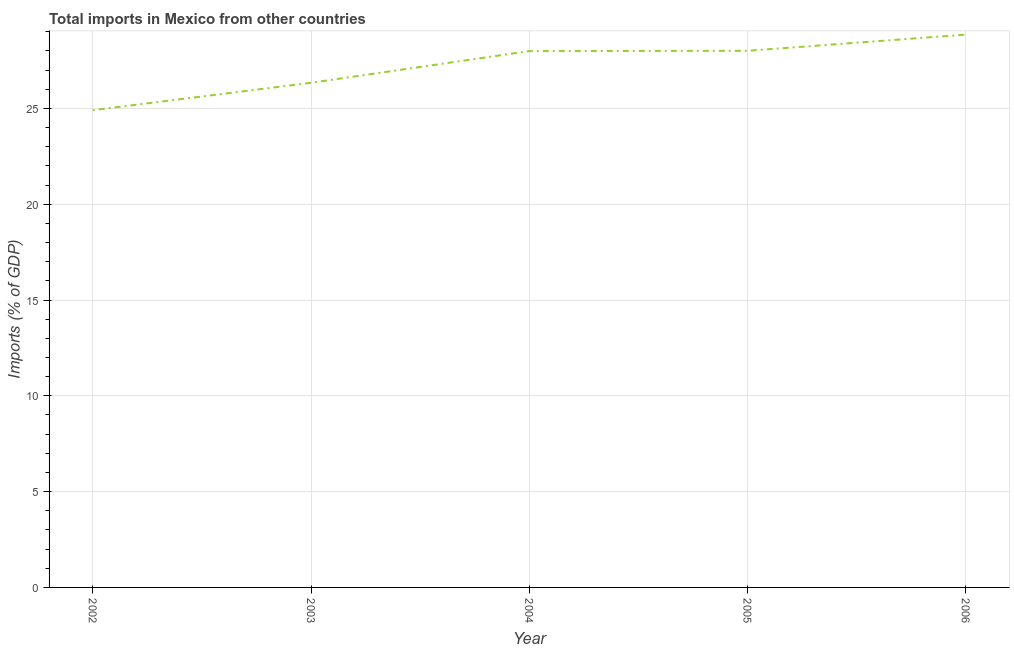What is the total imports in 2003?
Offer a very short reply. 26.34. Across all years, what is the maximum total imports?
Make the answer very short. 28.85. Across all years, what is the minimum total imports?
Your answer should be compact. 24.91. In which year was the total imports minimum?
Your response must be concise. 2002. What is the sum of the total imports?
Provide a short and direct response. 136.1. What is the difference between the total imports in 2004 and 2006?
Keep it short and to the point. -0.86. What is the average total imports per year?
Your response must be concise. 27.22. What is the median total imports?
Offer a terse response. 27.99. Do a majority of the years between 2004 and 2002 (inclusive) have total imports greater than 12 %?
Your response must be concise. No. What is the ratio of the total imports in 2004 to that in 2006?
Offer a very short reply. 0.97. What is the difference between the highest and the second highest total imports?
Give a very brief answer. 0.85. Is the sum of the total imports in 2002 and 2004 greater than the maximum total imports across all years?
Your response must be concise. Yes. What is the difference between the highest and the lowest total imports?
Your response must be concise. 3.95. Does the total imports monotonically increase over the years?
Ensure brevity in your answer.  Yes. How many lines are there?
Give a very brief answer. 1. What is the difference between two consecutive major ticks on the Y-axis?
Make the answer very short. 5. Does the graph contain any zero values?
Give a very brief answer. No. What is the title of the graph?
Your response must be concise. Total imports in Mexico from other countries. What is the label or title of the Y-axis?
Offer a very short reply. Imports (% of GDP). What is the Imports (% of GDP) of 2002?
Provide a short and direct response. 24.91. What is the Imports (% of GDP) of 2003?
Your response must be concise. 26.34. What is the Imports (% of GDP) of 2004?
Give a very brief answer. 27.99. What is the Imports (% of GDP) in 2005?
Ensure brevity in your answer.  28.01. What is the Imports (% of GDP) of 2006?
Provide a short and direct response. 28.85. What is the difference between the Imports (% of GDP) in 2002 and 2003?
Give a very brief answer. -1.43. What is the difference between the Imports (% of GDP) in 2002 and 2004?
Keep it short and to the point. -3.08. What is the difference between the Imports (% of GDP) in 2002 and 2005?
Your response must be concise. -3.1. What is the difference between the Imports (% of GDP) in 2002 and 2006?
Keep it short and to the point. -3.95. What is the difference between the Imports (% of GDP) in 2003 and 2004?
Your response must be concise. -1.65. What is the difference between the Imports (% of GDP) in 2003 and 2005?
Provide a succinct answer. -1.67. What is the difference between the Imports (% of GDP) in 2003 and 2006?
Provide a short and direct response. -2.51. What is the difference between the Imports (% of GDP) in 2004 and 2005?
Your answer should be very brief. -0.02. What is the difference between the Imports (% of GDP) in 2004 and 2006?
Keep it short and to the point. -0.86. What is the difference between the Imports (% of GDP) in 2005 and 2006?
Ensure brevity in your answer.  -0.85. What is the ratio of the Imports (% of GDP) in 2002 to that in 2003?
Your response must be concise. 0.95. What is the ratio of the Imports (% of GDP) in 2002 to that in 2004?
Keep it short and to the point. 0.89. What is the ratio of the Imports (% of GDP) in 2002 to that in 2005?
Your answer should be very brief. 0.89. What is the ratio of the Imports (% of GDP) in 2002 to that in 2006?
Offer a very short reply. 0.86. What is the ratio of the Imports (% of GDP) in 2003 to that in 2004?
Your response must be concise. 0.94. What is the ratio of the Imports (% of GDP) in 2004 to that in 2006?
Ensure brevity in your answer.  0.97. 